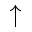Convert formula to latex. <formula><loc_0><loc_0><loc_500><loc_500>\uparrow</formula> 